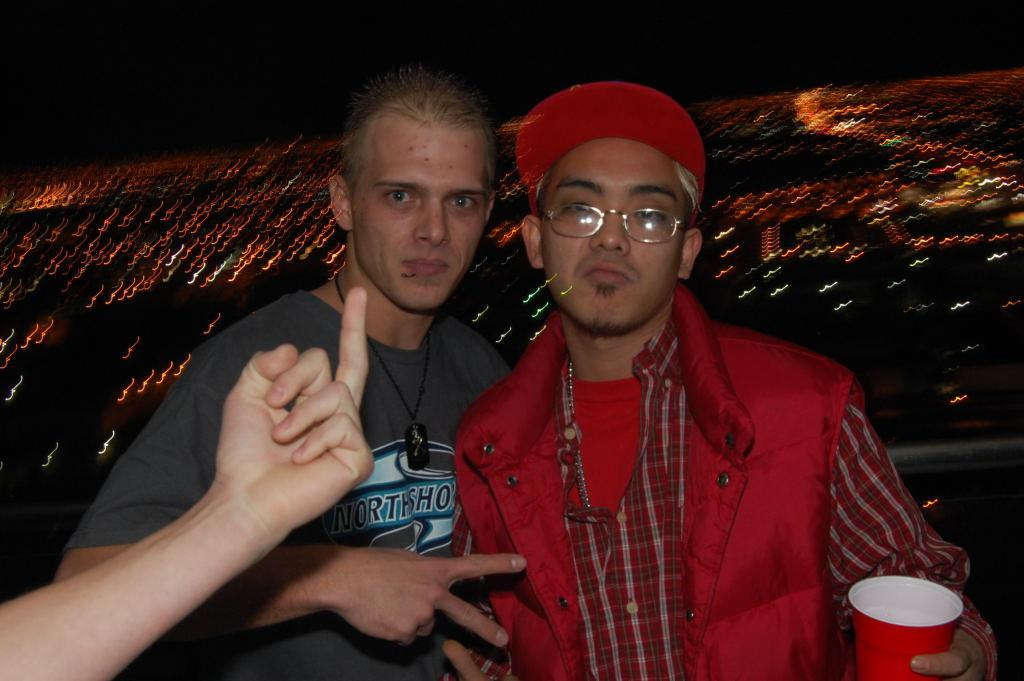How many people are in the image? There are two men standing in the image. What are the men doing in the image? The men are posing for a photo. Can you describe any additional elements in the image? There is a hand of another person on the left side of the image. Are there any ghosts visible in the image? No, there are no ghosts present in the image. What type of birds can be seen flying in the background of the image? There are no birds visible in the image. 